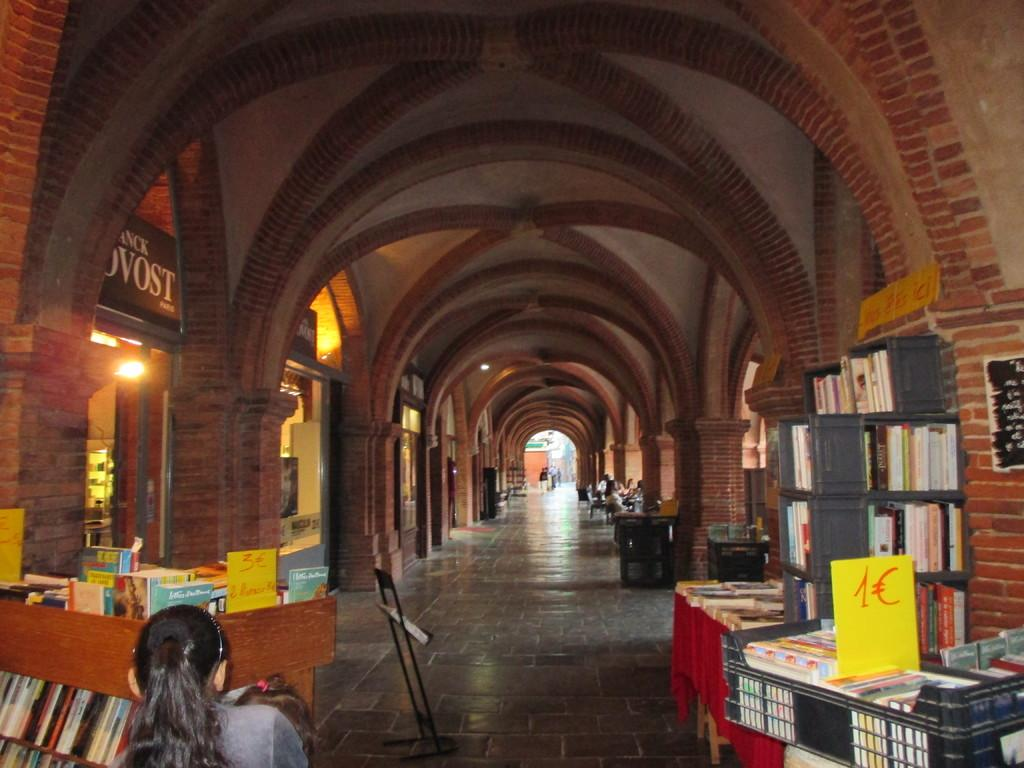Provide a one-sentence caption for the provided image. a long hall and a piece of paper with 1C on it. 